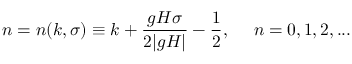<formula> <loc_0><loc_0><loc_500><loc_500>n = n ( k , \sigma ) \equiv k + \frac { g H \sigma } { 2 | g H | } - \frac { 1 } { 2 } , n = 0 , 1 , 2 , \dots</formula> 